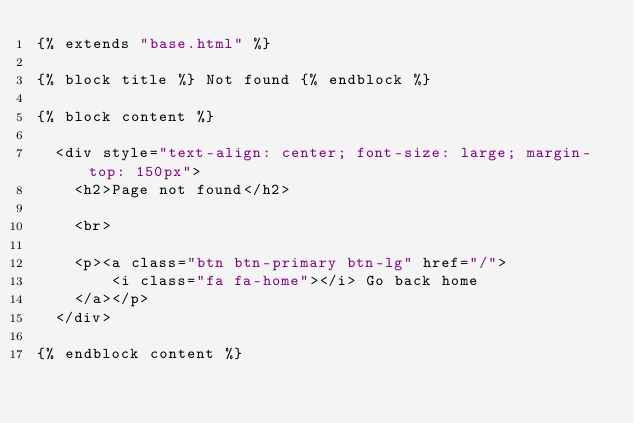Convert code to text. <code><loc_0><loc_0><loc_500><loc_500><_HTML_>{% extends "base.html" %}

{% block title %} Not found {% endblock %}

{% block content %}

  <div style="text-align: center; font-size: large; margin-top: 150px">
    <h2>Page not found</h2>

    <br>

    <p><a class="btn btn-primary btn-lg" href="/">
        <i class="fa fa-home"></i> Go back home
    </a></p>
  </div>

{% endblock content %}
</code> 